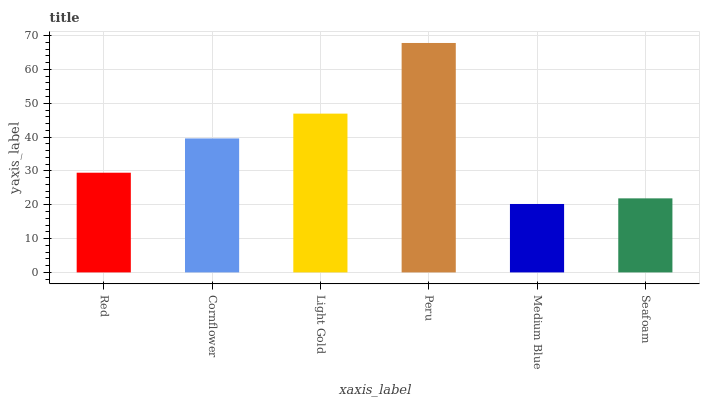Is Medium Blue the minimum?
Answer yes or no. Yes. Is Peru the maximum?
Answer yes or no. Yes. Is Cornflower the minimum?
Answer yes or no. No. Is Cornflower the maximum?
Answer yes or no. No. Is Cornflower greater than Red?
Answer yes or no. Yes. Is Red less than Cornflower?
Answer yes or no. Yes. Is Red greater than Cornflower?
Answer yes or no. No. Is Cornflower less than Red?
Answer yes or no. No. Is Cornflower the high median?
Answer yes or no. Yes. Is Red the low median?
Answer yes or no. Yes. Is Seafoam the high median?
Answer yes or no. No. Is Seafoam the low median?
Answer yes or no. No. 